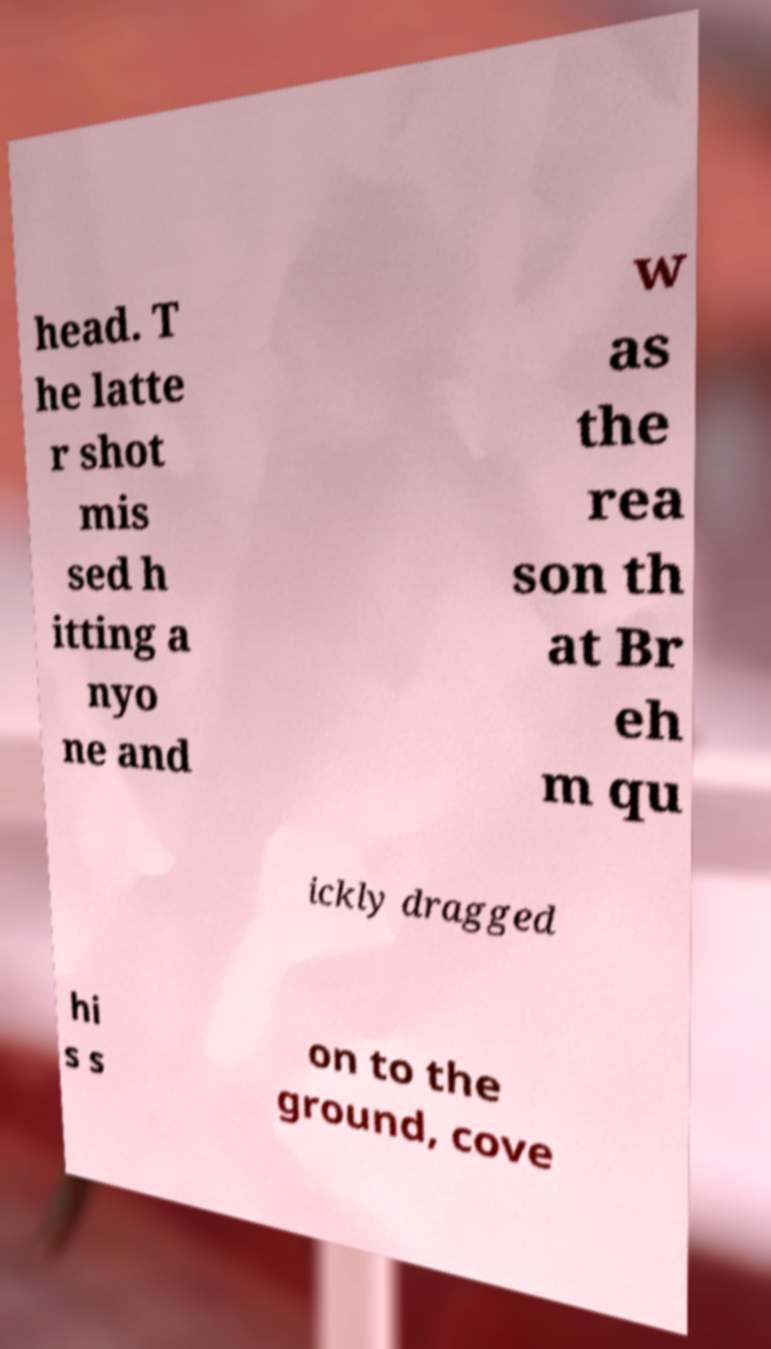Could you extract and type out the text from this image? head. T he latte r shot mis sed h itting a nyo ne and w as the rea son th at Br eh m qu ickly dragged hi s s on to the ground, cove 